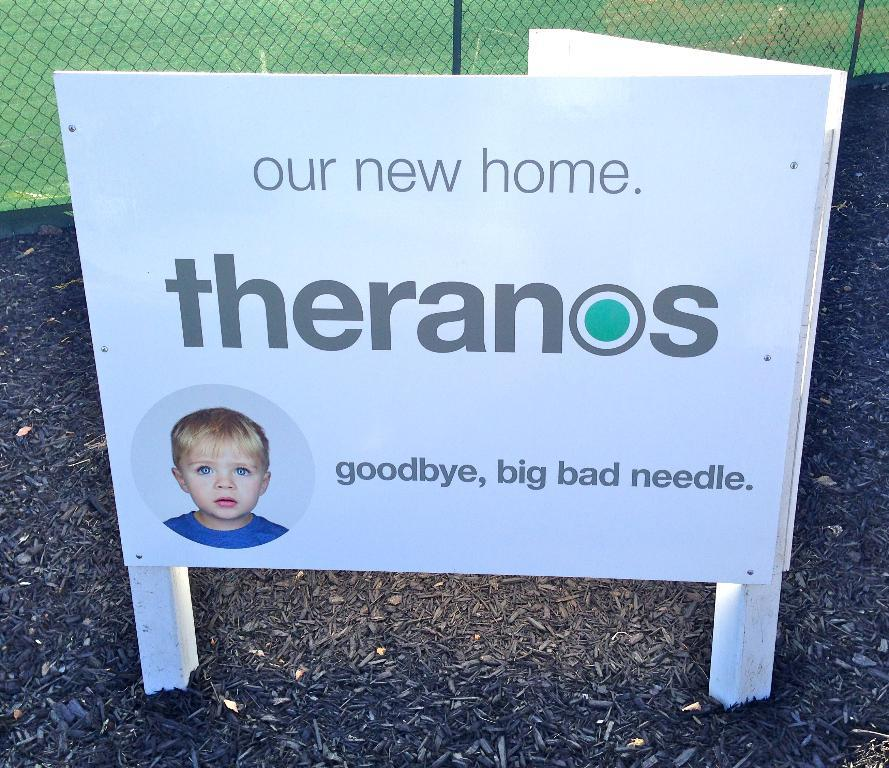What is the main object in the image? There is a white board in the image. What is happening on the white board? A person is on the white board. What can be seen in the background of the image? There is fencing in the background of the image. What type of ground is visible in the image? Grass is visible on the ground in the image. What type of substance is the person on the white board using to express hope? There is no substance or expression of hope visible in the image; it only shows a person on the white board and fencing in the background. 